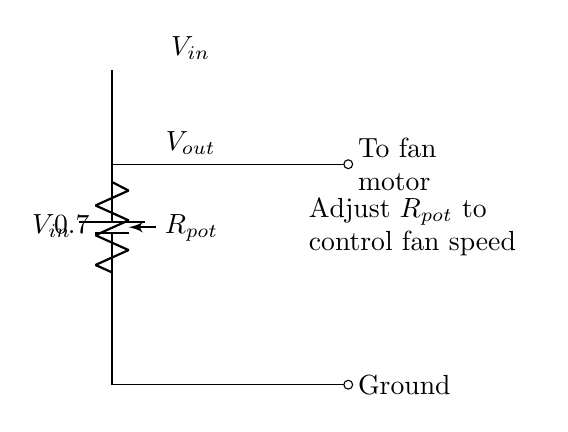What is the input voltage source labeled as? The input voltage source is labeled as V_in. This can be identified directly from the circuit diagram where the battery is depicted, and the label is placed adjacent to it.
Answer: V_in What component is used to control the speed of the fan? The component used to control the speed of the fan is the potentiometer. It is specifically indicated as R_pot in the circuit diagram, which allows for adjustable resistance to regulate the output voltage feeding the fan.
Answer: R_pot What is the output voltage represented in the circuit? The output voltage is represented as V_out, which is taken from the potentiometer to the fan in the circuit diagram. It labels the voltage that will actually control the fan speed.
Answer: V_out How does adjusting the potentiometer affect the fan? Adjusting the potentiometer changes its resistance, altering the V_out; thus, lower resistance leads to higher V_out, speeding up the fan, while higher resistance decreases V_out, slowing it down. This reasoning derives from understanding how a voltage divider operates and affects load characteristics.
Answer: Changes fan speed What happens to V_out when R_pot is maximized? When R_pot is maximized (i.e., set to its highest resistance), V_out approaches zero, meaning the output voltage is negligible. This occurs in voltage dividers when one resistor is unaltered, leading to the total voltage being dropped across the other resistor.
Answer: Approaches zero What is the connection type to the fan motor shown in the diagram? The connection from the circuit to the fan motor is shown as a short (a direct connection) and is indicated by the symbol "-o" in the diagram. This illustrates how the fan is directly connected to the output voltage produced by the voltage divider.
Answer: Short 